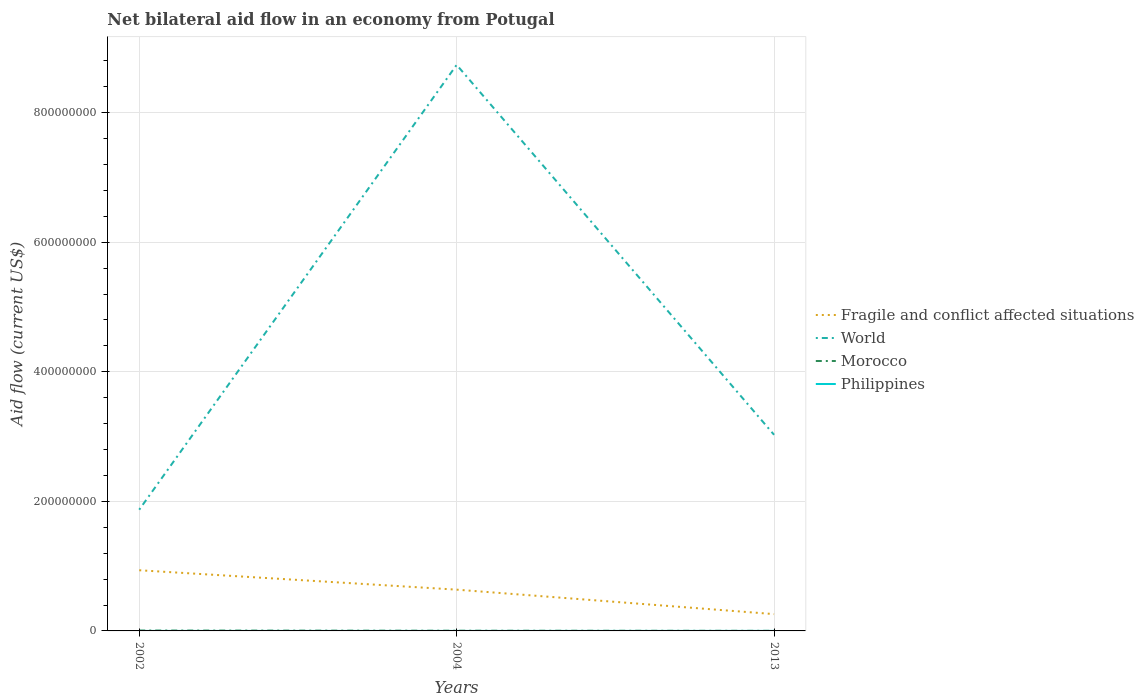Is the number of lines equal to the number of legend labels?
Ensure brevity in your answer.  Yes. Across all years, what is the maximum net bilateral aid flow in World?
Offer a very short reply. 1.87e+08. In which year was the net bilateral aid flow in World maximum?
Ensure brevity in your answer.  2002. What is the difference between the highest and the lowest net bilateral aid flow in Fragile and conflict affected situations?
Ensure brevity in your answer.  2. Is the net bilateral aid flow in Morocco strictly greater than the net bilateral aid flow in World over the years?
Provide a succinct answer. Yes. How many years are there in the graph?
Provide a short and direct response. 3. Are the values on the major ticks of Y-axis written in scientific E-notation?
Your answer should be compact. No. Does the graph contain any zero values?
Offer a very short reply. No. How are the legend labels stacked?
Ensure brevity in your answer.  Vertical. What is the title of the graph?
Provide a short and direct response. Net bilateral aid flow in an economy from Potugal. Does "Canada" appear as one of the legend labels in the graph?
Provide a short and direct response. No. What is the label or title of the Y-axis?
Your answer should be very brief. Aid flow (current US$). What is the Aid flow (current US$) of Fragile and conflict affected situations in 2002?
Offer a terse response. 9.37e+07. What is the Aid flow (current US$) of World in 2002?
Your response must be concise. 1.87e+08. What is the Aid flow (current US$) in Morocco in 2002?
Give a very brief answer. 5.70e+05. What is the Aid flow (current US$) of Fragile and conflict affected situations in 2004?
Make the answer very short. 6.37e+07. What is the Aid flow (current US$) of World in 2004?
Offer a terse response. 8.74e+08. What is the Aid flow (current US$) of Philippines in 2004?
Give a very brief answer. 10000. What is the Aid flow (current US$) of Fragile and conflict affected situations in 2013?
Provide a short and direct response. 2.60e+07. What is the Aid flow (current US$) in World in 2013?
Offer a very short reply. 3.03e+08. What is the Aid flow (current US$) in Philippines in 2013?
Your answer should be compact. 3.00e+04. Across all years, what is the maximum Aid flow (current US$) in Fragile and conflict affected situations?
Your answer should be very brief. 9.37e+07. Across all years, what is the maximum Aid flow (current US$) of World?
Give a very brief answer. 8.74e+08. Across all years, what is the maximum Aid flow (current US$) of Morocco?
Offer a very short reply. 5.70e+05. Across all years, what is the minimum Aid flow (current US$) in Fragile and conflict affected situations?
Provide a short and direct response. 2.60e+07. Across all years, what is the minimum Aid flow (current US$) of World?
Offer a very short reply. 1.87e+08. Across all years, what is the minimum Aid flow (current US$) of Philippines?
Make the answer very short. 10000. What is the total Aid flow (current US$) in Fragile and conflict affected situations in the graph?
Your response must be concise. 1.83e+08. What is the total Aid flow (current US$) in World in the graph?
Ensure brevity in your answer.  1.36e+09. What is the total Aid flow (current US$) in Morocco in the graph?
Offer a terse response. 1.00e+06. What is the difference between the Aid flow (current US$) in Fragile and conflict affected situations in 2002 and that in 2004?
Keep it short and to the point. 3.00e+07. What is the difference between the Aid flow (current US$) in World in 2002 and that in 2004?
Your response must be concise. -6.87e+08. What is the difference between the Aid flow (current US$) of Fragile and conflict affected situations in 2002 and that in 2013?
Offer a very short reply. 6.77e+07. What is the difference between the Aid flow (current US$) of World in 2002 and that in 2013?
Ensure brevity in your answer.  -1.16e+08. What is the difference between the Aid flow (current US$) in Morocco in 2002 and that in 2013?
Your response must be concise. 4.30e+05. What is the difference between the Aid flow (current US$) of Philippines in 2002 and that in 2013?
Keep it short and to the point. -2.00e+04. What is the difference between the Aid flow (current US$) of Fragile and conflict affected situations in 2004 and that in 2013?
Make the answer very short. 3.78e+07. What is the difference between the Aid flow (current US$) of World in 2004 and that in 2013?
Keep it short and to the point. 5.71e+08. What is the difference between the Aid flow (current US$) in Philippines in 2004 and that in 2013?
Provide a short and direct response. -2.00e+04. What is the difference between the Aid flow (current US$) in Fragile and conflict affected situations in 2002 and the Aid flow (current US$) in World in 2004?
Offer a very short reply. -7.80e+08. What is the difference between the Aid flow (current US$) of Fragile and conflict affected situations in 2002 and the Aid flow (current US$) of Morocco in 2004?
Give a very brief answer. 9.34e+07. What is the difference between the Aid flow (current US$) of Fragile and conflict affected situations in 2002 and the Aid flow (current US$) of Philippines in 2004?
Your answer should be very brief. 9.36e+07. What is the difference between the Aid flow (current US$) in World in 2002 and the Aid flow (current US$) in Morocco in 2004?
Make the answer very short. 1.87e+08. What is the difference between the Aid flow (current US$) of World in 2002 and the Aid flow (current US$) of Philippines in 2004?
Provide a succinct answer. 1.87e+08. What is the difference between the Aid flow (current US$) of Morocco in 2002 and the Aid flow (current US$) of Philippines in 2004?
Keep it short and to the point. 5.60e+05. What is the difference between the Aid flow (current US$) of Fragile and conflict affected situations in 2002 and the Aid flow (current US$) of World in 2013?
Your response must be concise. -2.09e+08. What is the difference between the Aid flow (current US$) of Fragile and conflict affected situations in 2002 and the Aid flow (current US$) of Morocco in 2013?
Make the answer very short. 9.35e+07. What is the difference between the Aid flow (current US$) of Fragile and conflict affected situations in 2002 and the Aid flow (current US$) of Philippines in 2013?
Provide a short and direct response. 9.36e+07. What is the difference between the Aid flow (current US$) of World in 2002 and the Aid flow (current US$) of Morocco in 2013?
Your response must be concise. 1.87e+08. What is the difference between the Aid flow (current US$) in World in 2002 and the Aid flow (current US$) in Philippines in 2013?
Your response must be concise. 1.87e+08. What is the difference between the Aid flow (current US$) in Morocco in 2002 and the Aid flow (current US$) in Philippines in 2013?
Provide a short and direct response. 5.40e+05. What is the difference between the Aid flow (current US$) in Fragile and conflict affected situations in 2004 and the Aid flow (current US$) in World in 2013?
Provide a short and direct response. -2.39e+08. What is the difference between the Aid flow (current US$) of Fragile and conflict affected situations in 2004 and the Aid flow (current US$) of Morocco in 2013?
Provide a short and direct response. 6.36e+07. What is the difference between the Aid flow (current US$) in Fragile and conflict affected situations in 2004 and the Aid flow (current US$) in Philippines in 2013?
Make the answer very short. 6.37e+07. What is the difference between the Aid flow (current US$) of World in 2004 and the Aid flow (current US$) of Morocco in 2013?
Keep it short and to the point. 8.74e+08. What is the difference between the Aid flow (current US$) in World in 2004 and the Aid flow (current US$) in Philippines in 2013?
Ensure brevity in your answer.  8.74e+08. What is the average Aid flow (current US$) of Fragile and conflict affected situations per year?
Give a very brief answer. 6.11e+07. What is the average Aid flow (current US$) in World per year?
Offer a very short reply. 4.55e+08. What is the average Aid flow (current US$) in Morocco per year?
Your response must be concise. 3.33e+05. What is the average Aid flow (current US$) in Philippines per year?
Offer a very short reply. 1.67e+04. In the year 2002, what is the difference between the Aid flow (current US$) in Fragile and conflict affected situations and Aid flow (current US$) in World?
Provide a short and direct response. -9.35e+07. In the year 2002, what is the difference between the Aid flow (current US$) in Fragile and conflict affected situations and Aid flow (current US$) in Morocco?
Offer a terse response. 9.31e+07. In the year 2002, what is the difference between the Aid flow (current US$) in Fragile and conflict affected situations and Aid flow (current US$) in Philippines?
Ensure brevity in your answer.  9.36e+07. In the year 2002, what is the difference between the Aid flow (current US$) of World and Aid flow (current US$) of Morocco?
Provide a short and direct response. 1.87e+08. In the year 2002, what is the difference between the Aid flow (current US$) of World and Aid flow (current US$) of Philippines?
Your answer should be very brief. 1.87e+08. In the year 2002, what is the difference between the Aid flow (current US$) of Morocco and Aid flow (current US$) of Philippines?
Provide a short and direct response. 5.60e+05. In the year 2004, what is the difference between the Aid flow (current US$) of Fragile and conflict affected situations and Aid flow (current US$) of World?
Give a very brief answer. -8.10e+08. In the year 2004, what is the difference between the Aid flow (current US$) in Fragile and conflict affected situations and Aid flow (current US$) in Morocco?
Provide a short and direct response. 6.34e+07. In the year 2004, what is the difference between the Aid flow (current US$) of Fragile and conflict affected situations and Aid flow (current US$) of Philippines?
Offer a very short reply. 6.37e+07. In the year 2004, what is the difference between the Aid flow (current US$) in World and Aid flow (current US$) in Morocco?
Give a very brief answer. 8.74e+08. In the year 2004, what is the difference between the Aid flow (current US$) in World and Aid flow (current US$) in Philippines?
Offer a very short reply. 8.74e+08. In the year 2004, what is the difference between the Aid flow (current US$) of Morocco and Aid flow (current US$) of Philippines?
Your response must be concise. 2.80e+05. In the year 2013, what is the difference between the Aid flow (current US$) in Fragile and conflict affected situations and Aid flow (current US$) in World?
Offer a very short reply. -2.77e+08. In the year 2013, what is the difference between the Aid flow (current US$) of Fragile and conflict affected situations and Aid flow (current US$) of Morocco?
Your answer should be very brief. 2.58e+07. In the year 2013, what is the difference between the Aid flow (current US$) of Fragile and conflict affected situations and Aid flow (current US$) of Philippines?
Offer a terse response. 2.59e+07. In the year 2013, what is the difference between the Aid flow (current US$) of World and Aid flow (current US$) of Morocco?
Your response must be concise. 3.03e+08. In the year 2013, what is the difference between the Aid flow (current US$) of World and Aid flow (current US$) of Philippines?
Keep it short and to the point. 3.03e+08. What is the ratio of the Aid flow (current US$) of Fragile and conflict affected situations in 2002 to that in 2004?
Your answer should be very brief. 1.47. What is the ratio of the Aid flow (current US$) of World in 2002 to that in 2004?
Your response must be concise. 0.21. What is the ratio of the Aid flow (current US$) of Morocco in 2002 to that in 2004?
Provide a succinct answer. 1.97. What is the ratio of the Aid flow (current US$) in Philippines in 2002 to that in 2004?
Provide a short and direct response. 1. What is the ratio of the Aid flow (current US$) in Fragile and conflict affected situations in 2002 to that in 2013?
Give a very brief answer. 3.61. What is the ratio of the Aid flow (current US$) in World in 2002 to that in 2013?
Your response must be concise. 0.62. What is the ratio of the Aid flow (current US$) of Morocco in 2002 to that in 2013?
Give a very brief answer. 4.07. What is the ratio of the Aid flow (current US$) of Fragile and conflict affected situations in 2004 to that in 2013?
Provide a succinct answer. 2.46. What is the ratio of the Aid flow (current US$) in World in 2004 to that in 2013?
Your response must be concise. 2.89. What is the ratio of the Aid flow (current US$) of Morocco in 2004 to that in 2013?
Give a very brief answer. 2.07. What is the difference between the highest and the second highest Aid flow (current US$) of Fragile and conflict affected situations?
Give a very brief answer. 3.00e+07. What is the difference between the highest and the second highest Aid flow (current US$) in World?
Provide a succinct answer. 5.71e+08. What is the difference between the highest and the second highest Aid flow (current US$) in Philippines?
Make the answer very short. 2.00e+04. What is the difference between the highest and the lowest Aid flow (current US$) of Fragile and conflict affected situations?
Your response must be concise. 6.77e+07. What is the difference between the highest and the lowest Aid flow (current US$) in World?
Provide a succinct answer. 6.87e+08. What is the difference between the highest and the lowest Aid flow (current US$) in Morocco?
Make the answer very short. 4.30e+05. 